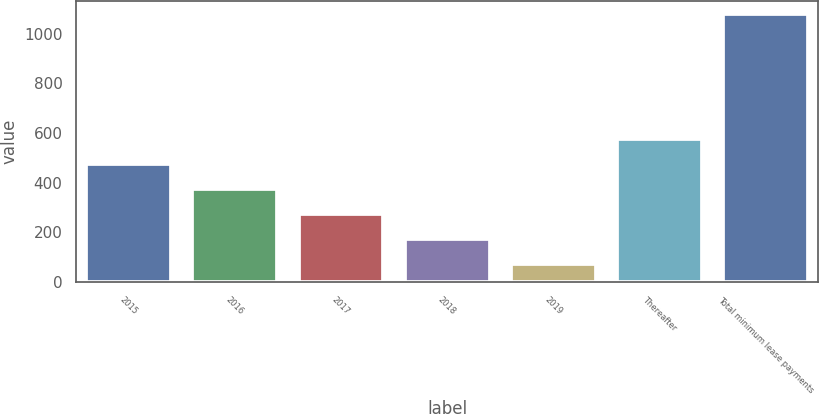<chart> <loc_0><loc_0><loc_500><loc_500><bar_chart><fcel>2015<fcel>2016<fcel>2017<fcel>2018<fcel>2019<fcel>Thereafter<fcel>Total minimum lease payments<nl><fcel>474.4<fcel>373.8<fcel>273.2<fcel>172.6<fcel>72<fcel>575<fcel>1078<nl></chart> 